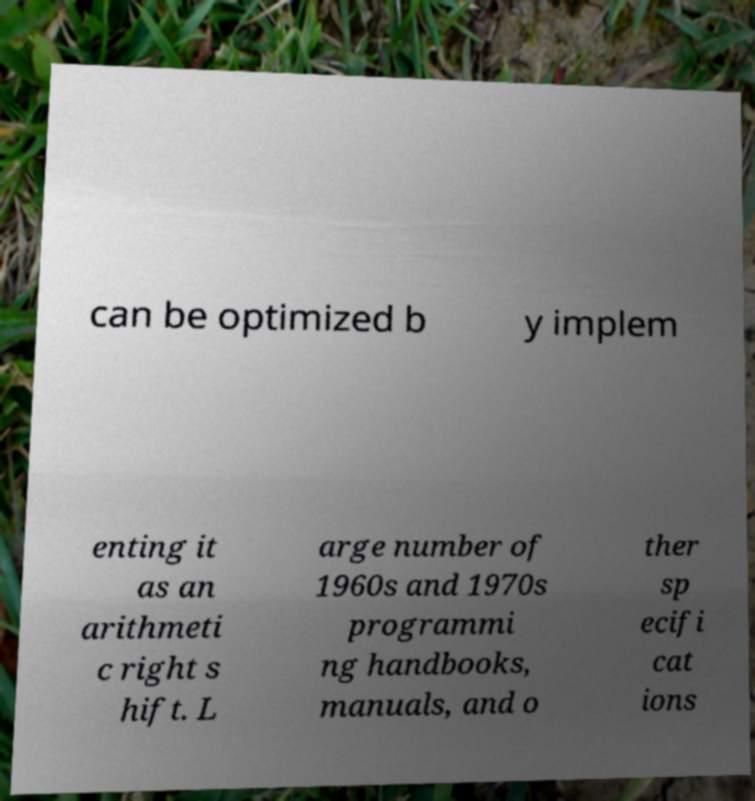There's text embedded in this image that I need extracted. Can you transcribe it verbatim? can be optimized b y implem enting it as an arithmeti c right s hift. L arge number of 1960s and 1970s programmi ng handbooks, manuals, and o ther sp ecifi cat ions 